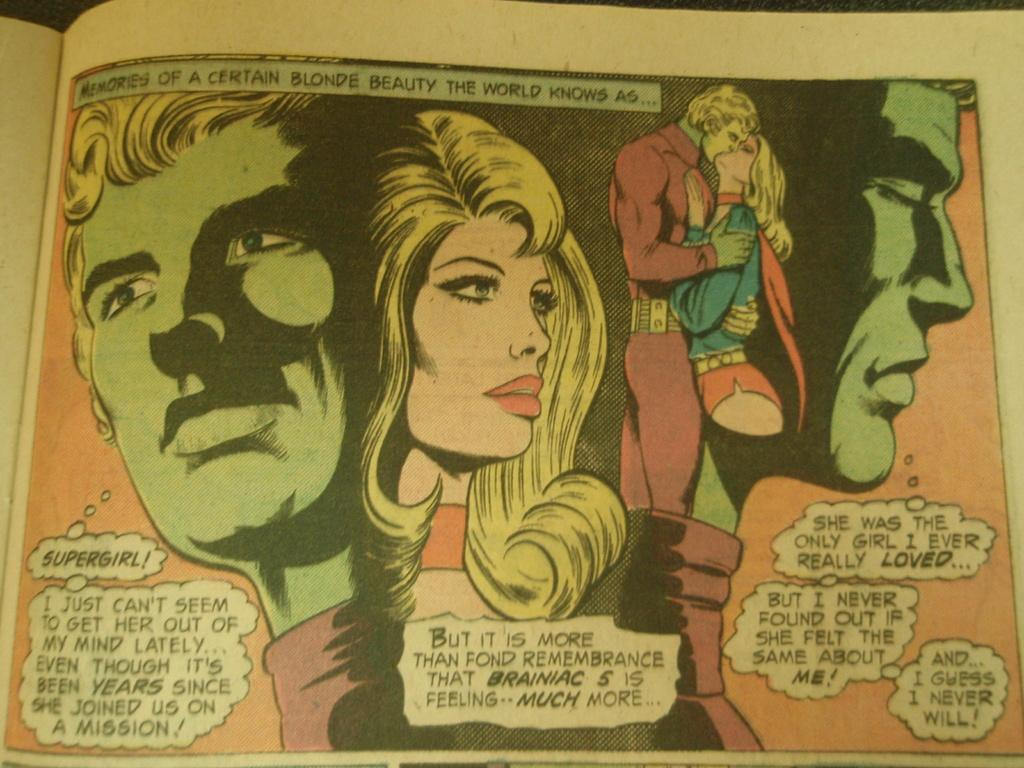Provide a one-sentence caption for the provided image. A superhero muses about his feelings about Supergirl in a comic book. 